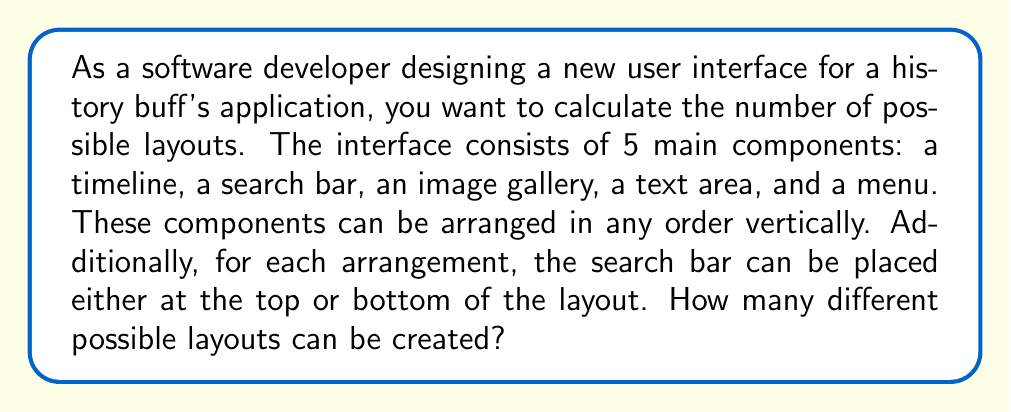Could you help me with this problem? Let's approach this problem step by step using combinatorics:

1) First, let's consider the arrangement of the 5 main components:
   - This is a permutation problem, as the order matters.
   - The number of permutations of 5 distinct objects is $5!$.

2) Now, for each of these permutations, we have two options for the search bar placement (top or bottom).
   - This doubles the number of possibilities for each permutation.

3) We can calculate the total number of layouts using the multiplication principle:
   
   $$ \text{Total layouts} = \text{Number of permutations} \times \text{Search bar options} $$
   $$ = 5! \times 2 $$

4) Let's calculate this:
   $$ 5! = 5 \times 4 \times 3 \times 2 \times 1 = 120 $$
   $$ 120 \times 2 = 240 $$

Therefore, there are 240 possible different layouts for the user interface.

This combinatorial approach allows for efficient calculation of possibilities without having to manually list out each option, which is particularly useful in software development when considering user interface design variations.
Answer: $240$ possible layouts 